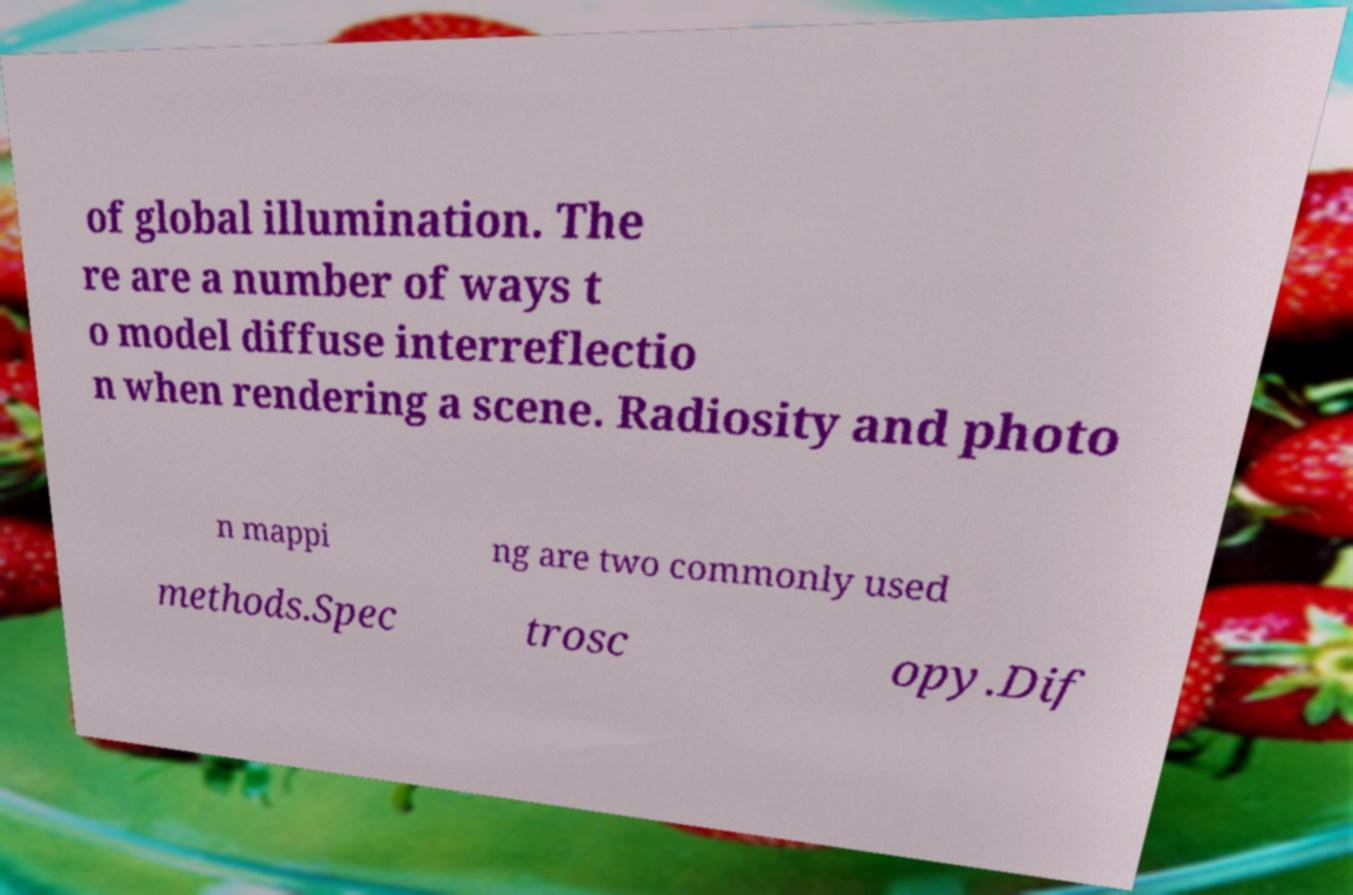There's text embedded in this image that I need extracted. Can you transcribe it verbatim? of global illumination. The re are a number of ways t o model diffuse interreflectio n when rendering a scene. Radiosity and photo n mappi ng are two commonly used methods.Spec trosc opy.Dif 